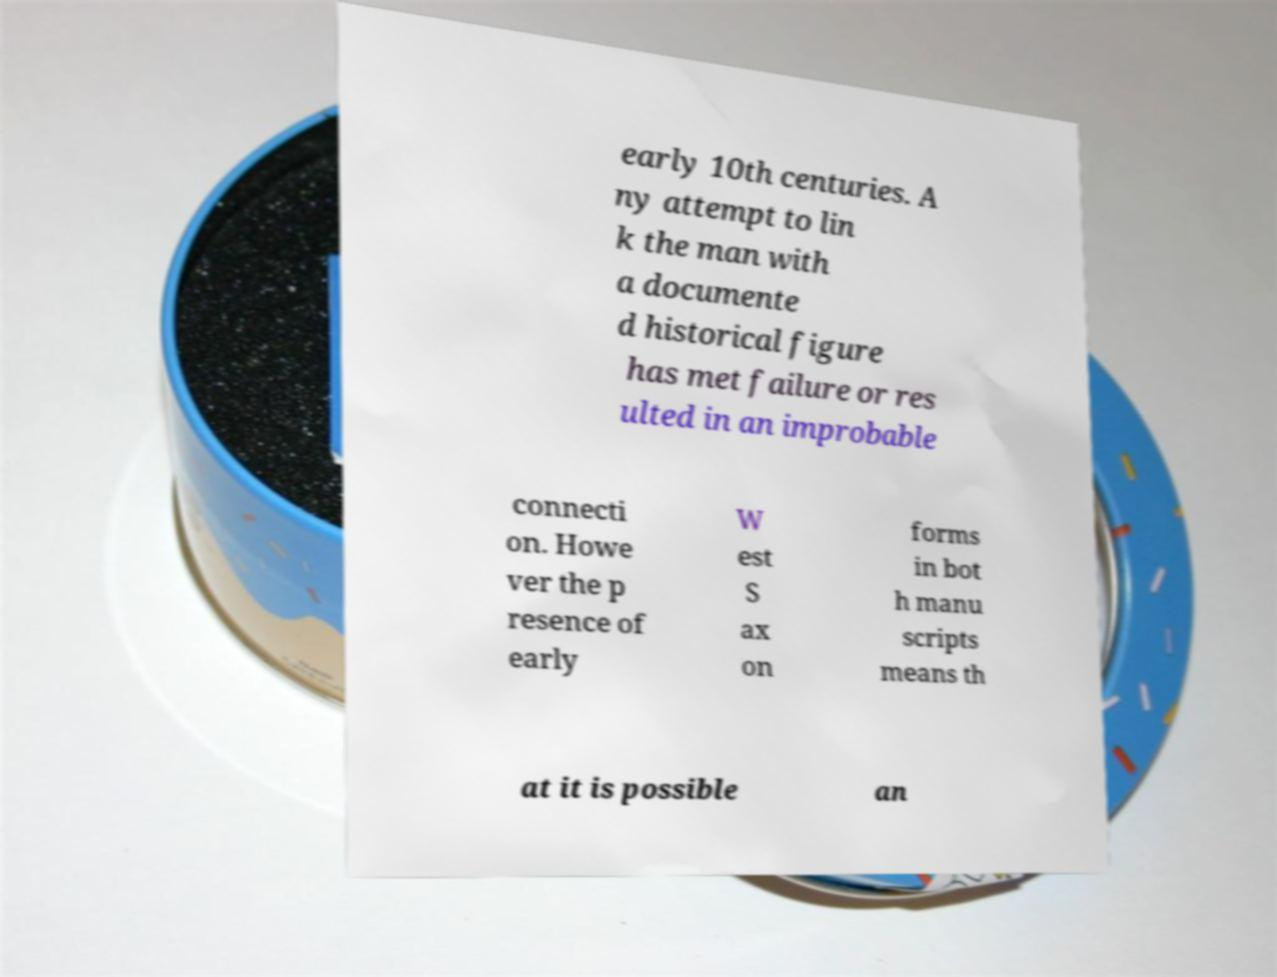For documentation purposes, I need the text within this image transcribed. Could you provide that? early 10th centuries. A ny attempt to lin k the man with a documente d historical figure has met failure or res ulted in an improbable connecti on. Howe ver the p resence of early W est S ax on forms in bot h manu scripts means th at it is possible an 